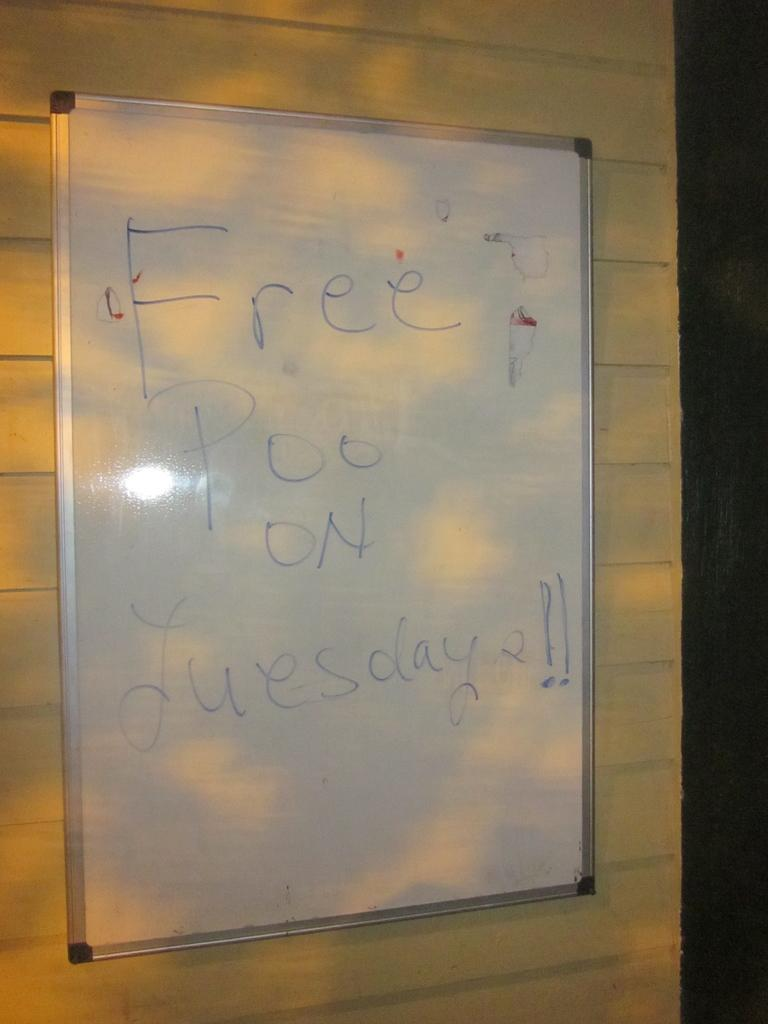<image>
Give a short and clear explanation of the subsequent image. a whiteboard with blue marker saying free poo on tuesdays 